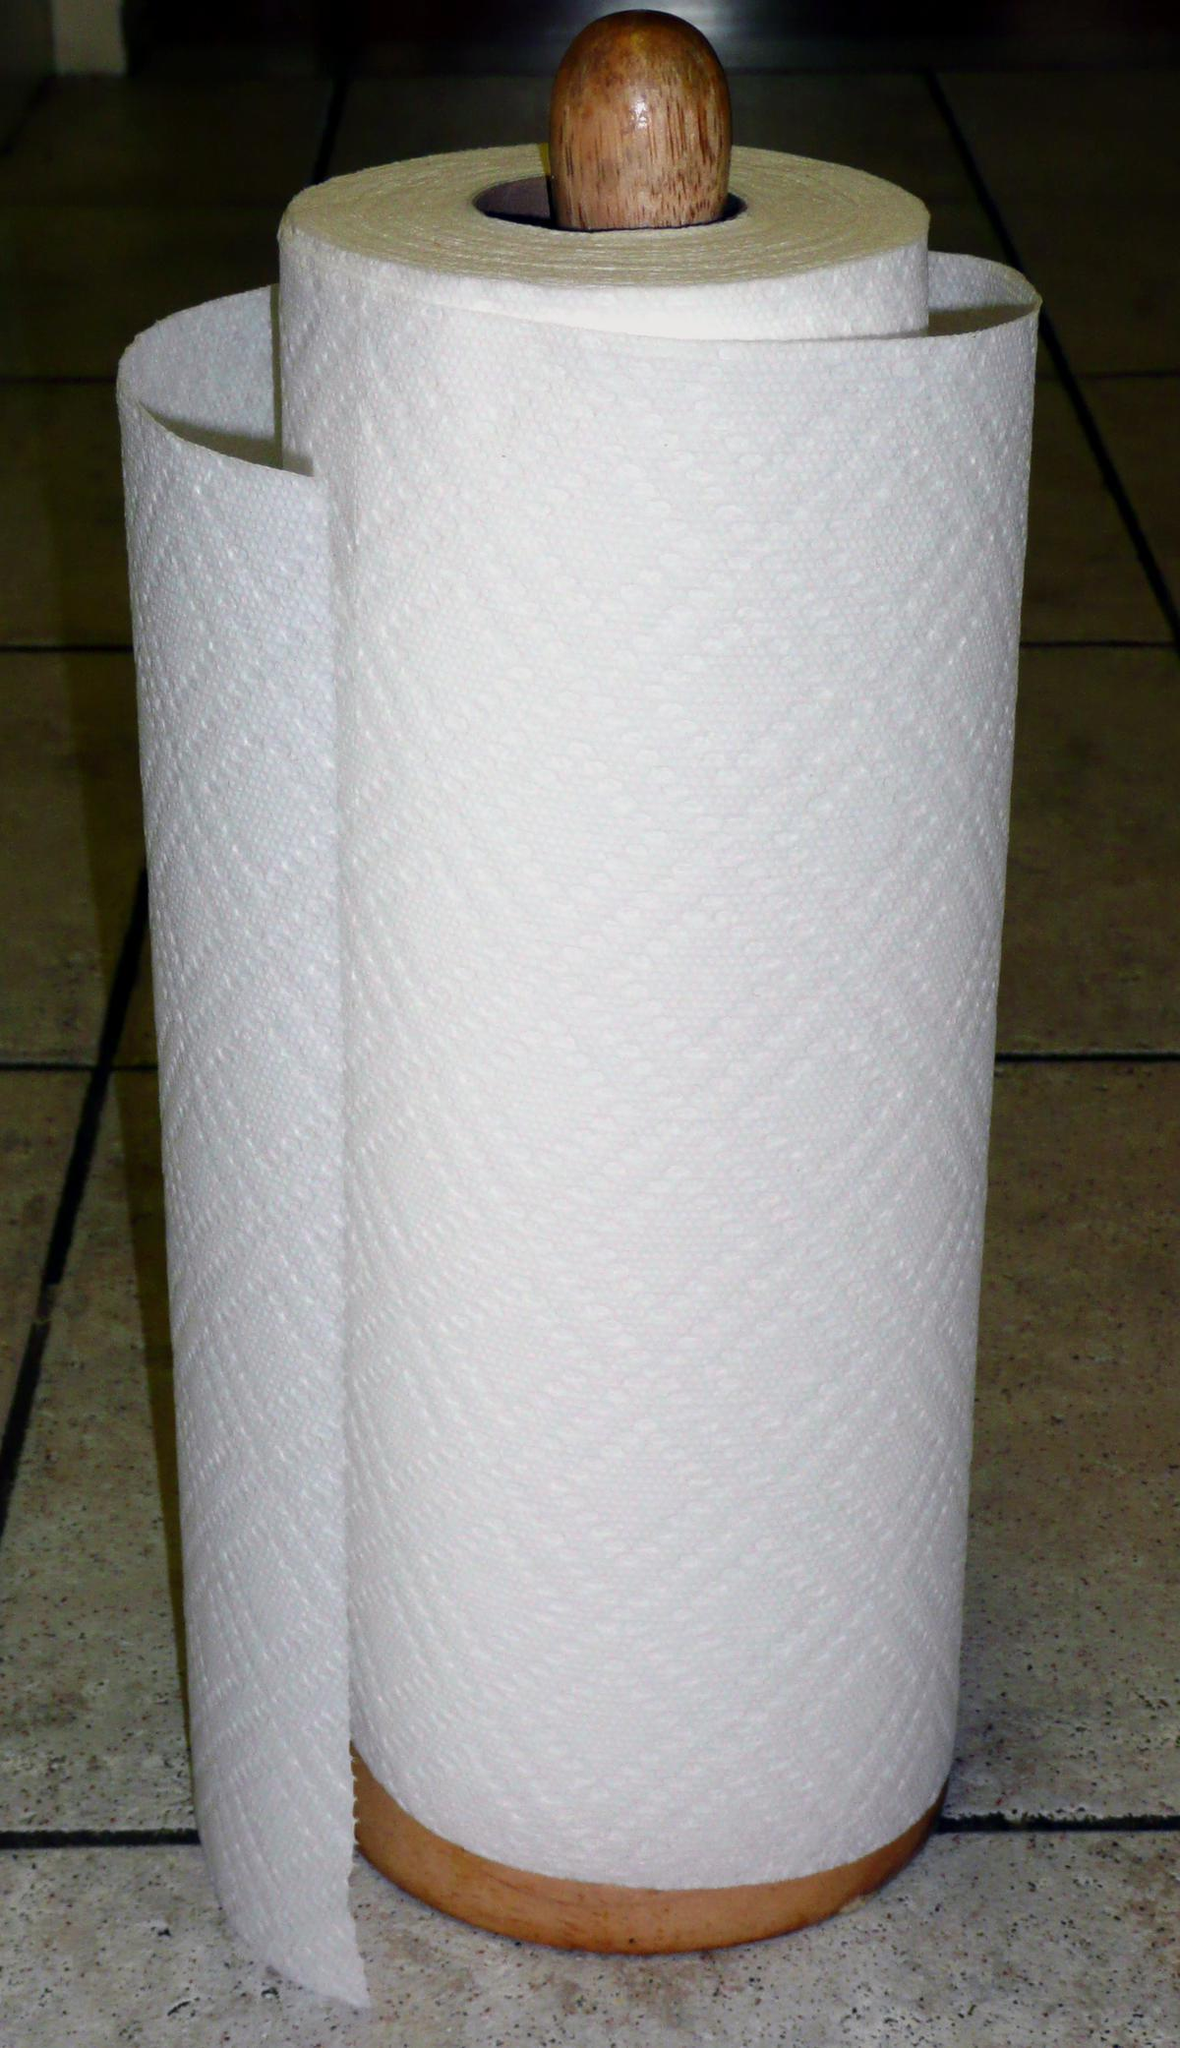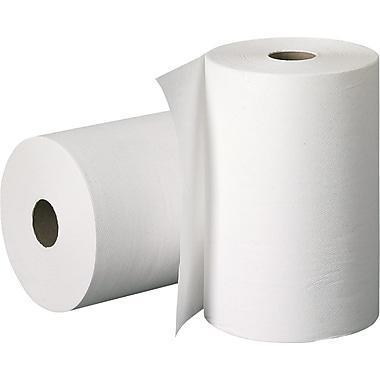The first image is the image on the left, the second image is the image on the right. Evaluate the accuracy of this statement regarding the images: "There are more than two rolls in each image.". Is it true? Answer yes or no. No. 